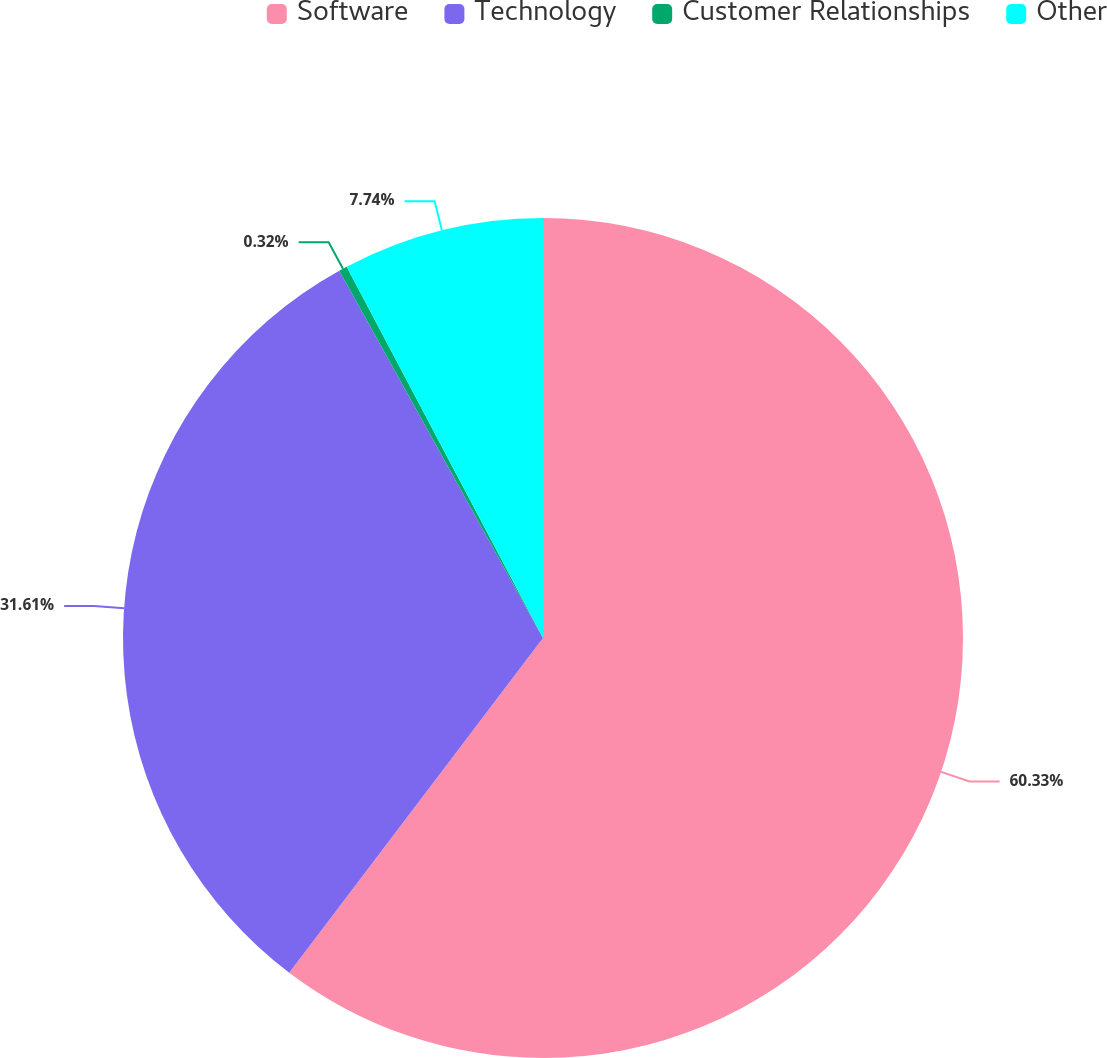<chart> <loc_0><loc_0><loc_500><loc_500><pie_chart><fcel>Software<fcel>Technology<fcel>Customer Relationships<fcel>Other<nl><fcel>60.32%<fcel>31.61%<fcel>0.32%<fcel>7.74%<nl></chart> 